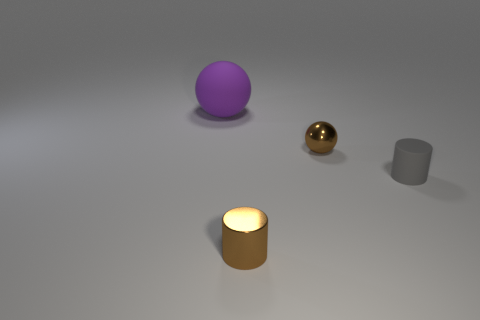How many objects are either matte things or objects that are in front of the purple sphere?
Provide a short and direct response. 4. There is a shiny object in front of the gray cylinder; is it the same shape as the matte thing right of the small brown cylinder?
Keep it short and to the point. Yes. Are there any other things that are the same color as the large rubber object?
Your response must be concise. No. There is a tiny thing that is made of the same material as the large object; what shape is it?
Give a very brief answer. Cylinder. There is a thing that is both to the left of the tiny sphere and behind the gray rubber thing; what is its material?
Ensure brevity in your answer.  Rubber. Is there anything else that has the same size as the purple object?
Offer a terse response. No. Is the tiny metal sphere the same color as the tiny metal cylinder?
Provide a short and direct response. Yes. What shape is the small metallic thing that is the same color as the tiny shiny cylinder?
Your answer should be compact. Sphere. What number of other big purple rubber objects are the same shape as the purple object?
Give a very brief answer. 0. There is a cylinder that is made of the same material as the large purple thing; what size is it?
Your answer should be very brief. Small. 